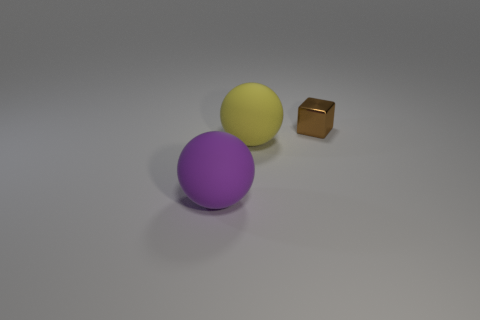Are there any other things that are the same material as the small brown cube?
Make the answer very short. No. Are there any other things that have the same size as the metal object?
Give a very brief answer. No. What color is the thing that is behind the matte thing that is to the right of the big matte sphere that is to the left of the yellow ball?
Ensure brevity in your answer.  Brown. The thing on the right side of the large yellow sphere has what shape?
Offer a terse response. Cube. There is another object that is made of the same material as the big purple thing; what shape is it?
Make the answer very short. Sphere. Are there any other things that are the same shape as the brown metallic thing?
Offer a terse response. No. How many purple things are left of the tiny brown metal cube?
Keep it short and to the point. 1. Are there an equal number of brown shiny cubes in front of the tiny brown cube and blue rubber blocks?
Your answer should be compact. Yes. Does the big purple sphere have the same material as the tiny brown thing?
Keep it short and to the point. No. What size is the object that is on the right side of the big purple object and in front of the tiny cube?
Provide a succinct answer. Large. 